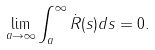Convert formula to latex. <formula><loc_0><loc_0><loc_500><loc_500>\lim _ { a \to \infty } \int _ { a } ^ { \infty } \dot { R } ( s ) d s = 0 .</formula> 